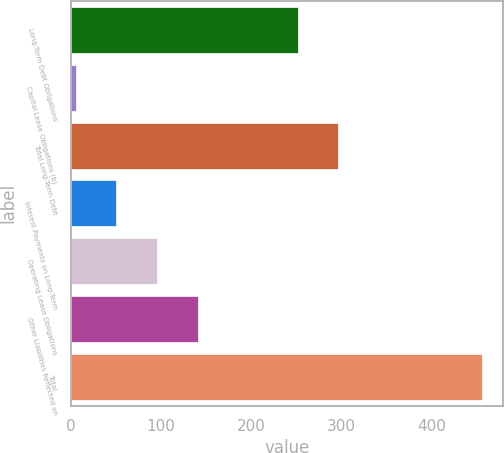<chart> <loc_0><loc_0><loc_500><loc_500><bar_chart><fcel>Long-Term Debt Obligations<fcel>Capital Lease Obligations (b)<fcel>Total Long-Term Debt<fcel>Interest Payments on Long-Term<fcel>Operating Lease Obligations<fcel>Other Liabilities Reflected on<fcel>Total<nl><fcel>251.4<fcel>5.6<fcel>296.39<fcel>50.59<fcel>95.58<fcel>140.57<fcel>455.5<nl></chart> 